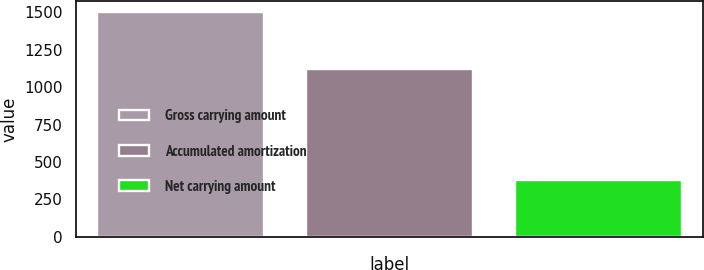Convert chart. <chart><loc_0><loc_0><loc_500><loc_500><bar_chart><fcel>Gross carrying amount<fcel>Accumulated amortization<fcel>Net carrying amount<nl><fcel>1499<fcel>1120<fcel>379<nl></chart> 